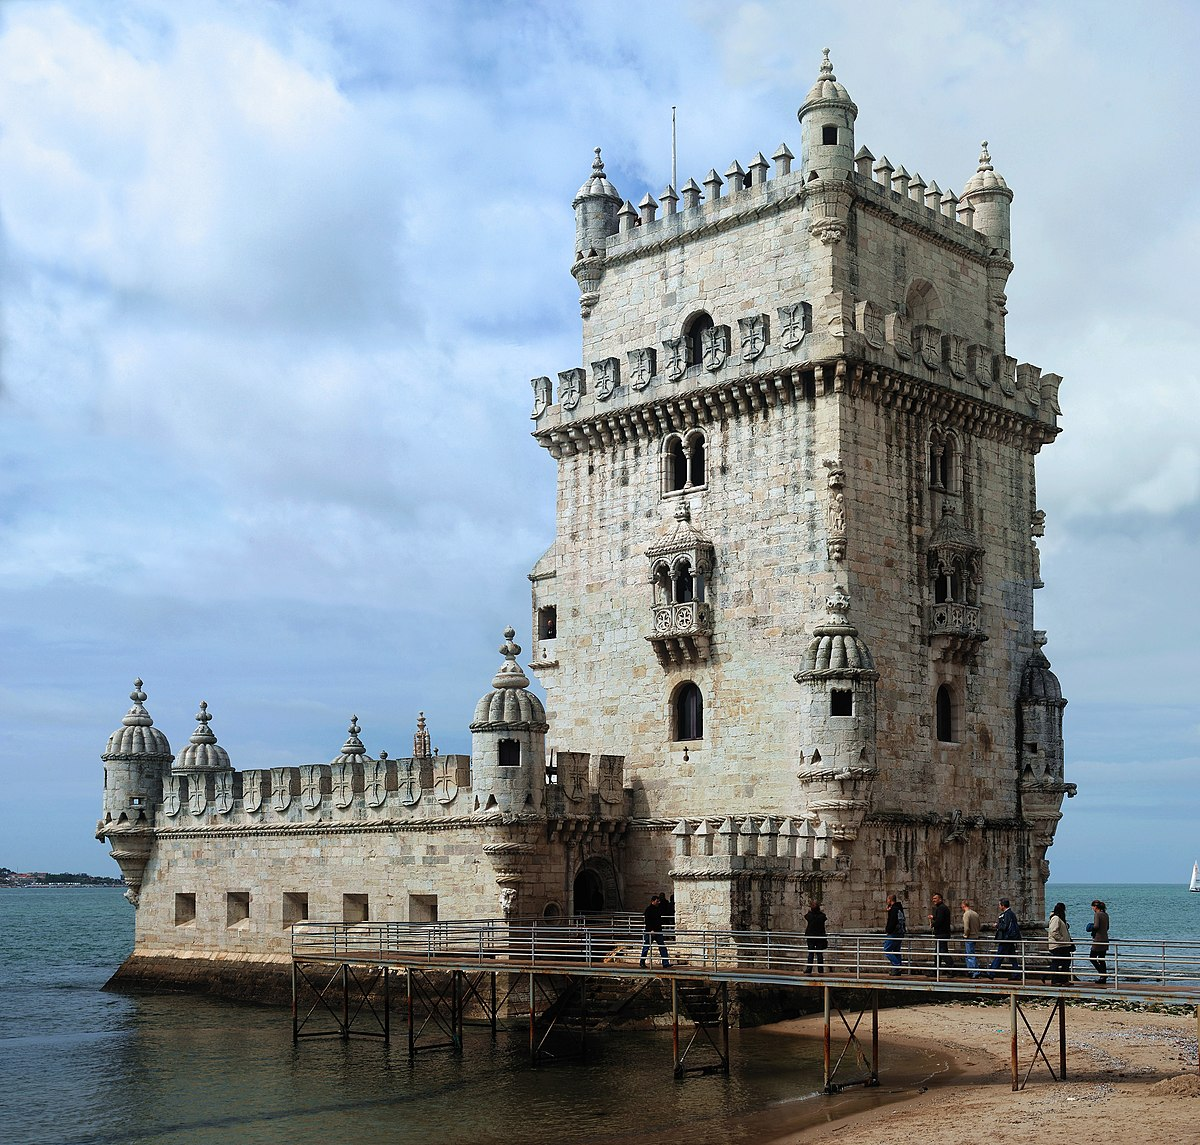What details in this image highlight the Manueline style? The Belem Tower's Manueline style is vividly highlighted through several architectural details observable in this image. Prominently, the ornate carvings that include maritime motifs such as armillary spheres, ropes, and nautical elements are indicative of this style. The intricate stonework around the windows and the balconies, along with the turrets that feature motifs of the cross of the Order of Christ, further emphasize the unique blend of Gothic and Renaissance elements typical of Manueline architecture. 